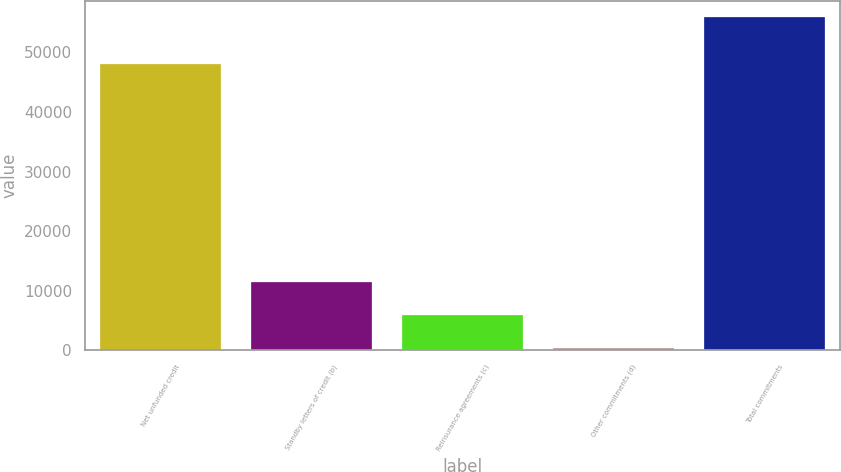Convert chart to OTSL. <chart><loc_0><loc_0><loc_500><loc_500><bar_chart><fcel>Net unfunded credit<fcel>Standby letters of credit (b)<fcel>Reinsurance agreements (c)<fcel>Other commitments (d)<fcel>Total commitments<nl><fcel>48011<fcel>11468.4<fcel>5917.7<fcel>367<fcel>55874<nl></chart> 